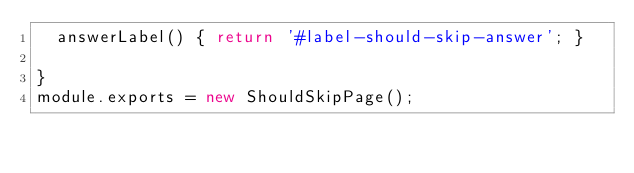<code> <loc_0><loc_0><loc_500><loc_500><_JavaScript_>  answerLabel() { return '#label-should-skip-answer'; }

}
module.exports = new ShouldSkipPage();
</code> 